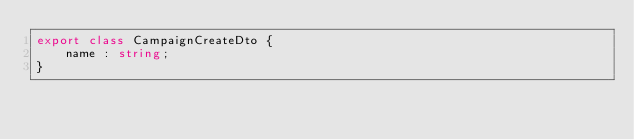<code> <loc_0><loc_0><loc_500><loc_500><_TypeScript_>export class CampaignCreateDto {
    name : string;
}</code> 